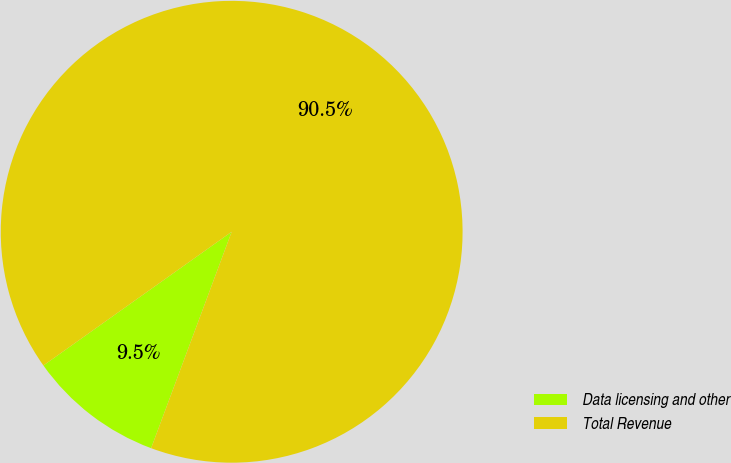<chart> <loc_0><loc_0><loc_500><loc_500><pie_chart><fcel>Data licensing and other<fcel>Total Revenue<nl><fcel>9.5%<fcel>90.5%<nl></chart> 